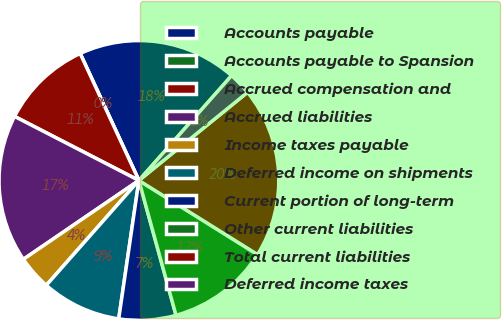<chart> <loc_0><loc_0><loc_500><loc_500><pie_chart><fcel>Accounts payable<fcel>Accounts payable to Spansion<fcel>Accrued compensation and<fcel>Accrued liabilities<fcel>Income taxes payable<fcel>Deferred income on shipments<fcel>Current portion of long-term<fcel>Other current liabilities<fcel>Total current liabilities<fcel>Deferred income taxes<nl><fcel>18.42%<fcel>0.0%<fcel>10.53%<fcel>17.1%<fcel>3.95%<fcel>9.21%<fcel>6.58%<fcel>11.84%<fcel>19.73%<fcel>2.63%<nl></chart> 